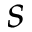Convert formula to latex. <formula><loc_0><loc_0><loc_500><loc_500>s</formula> 